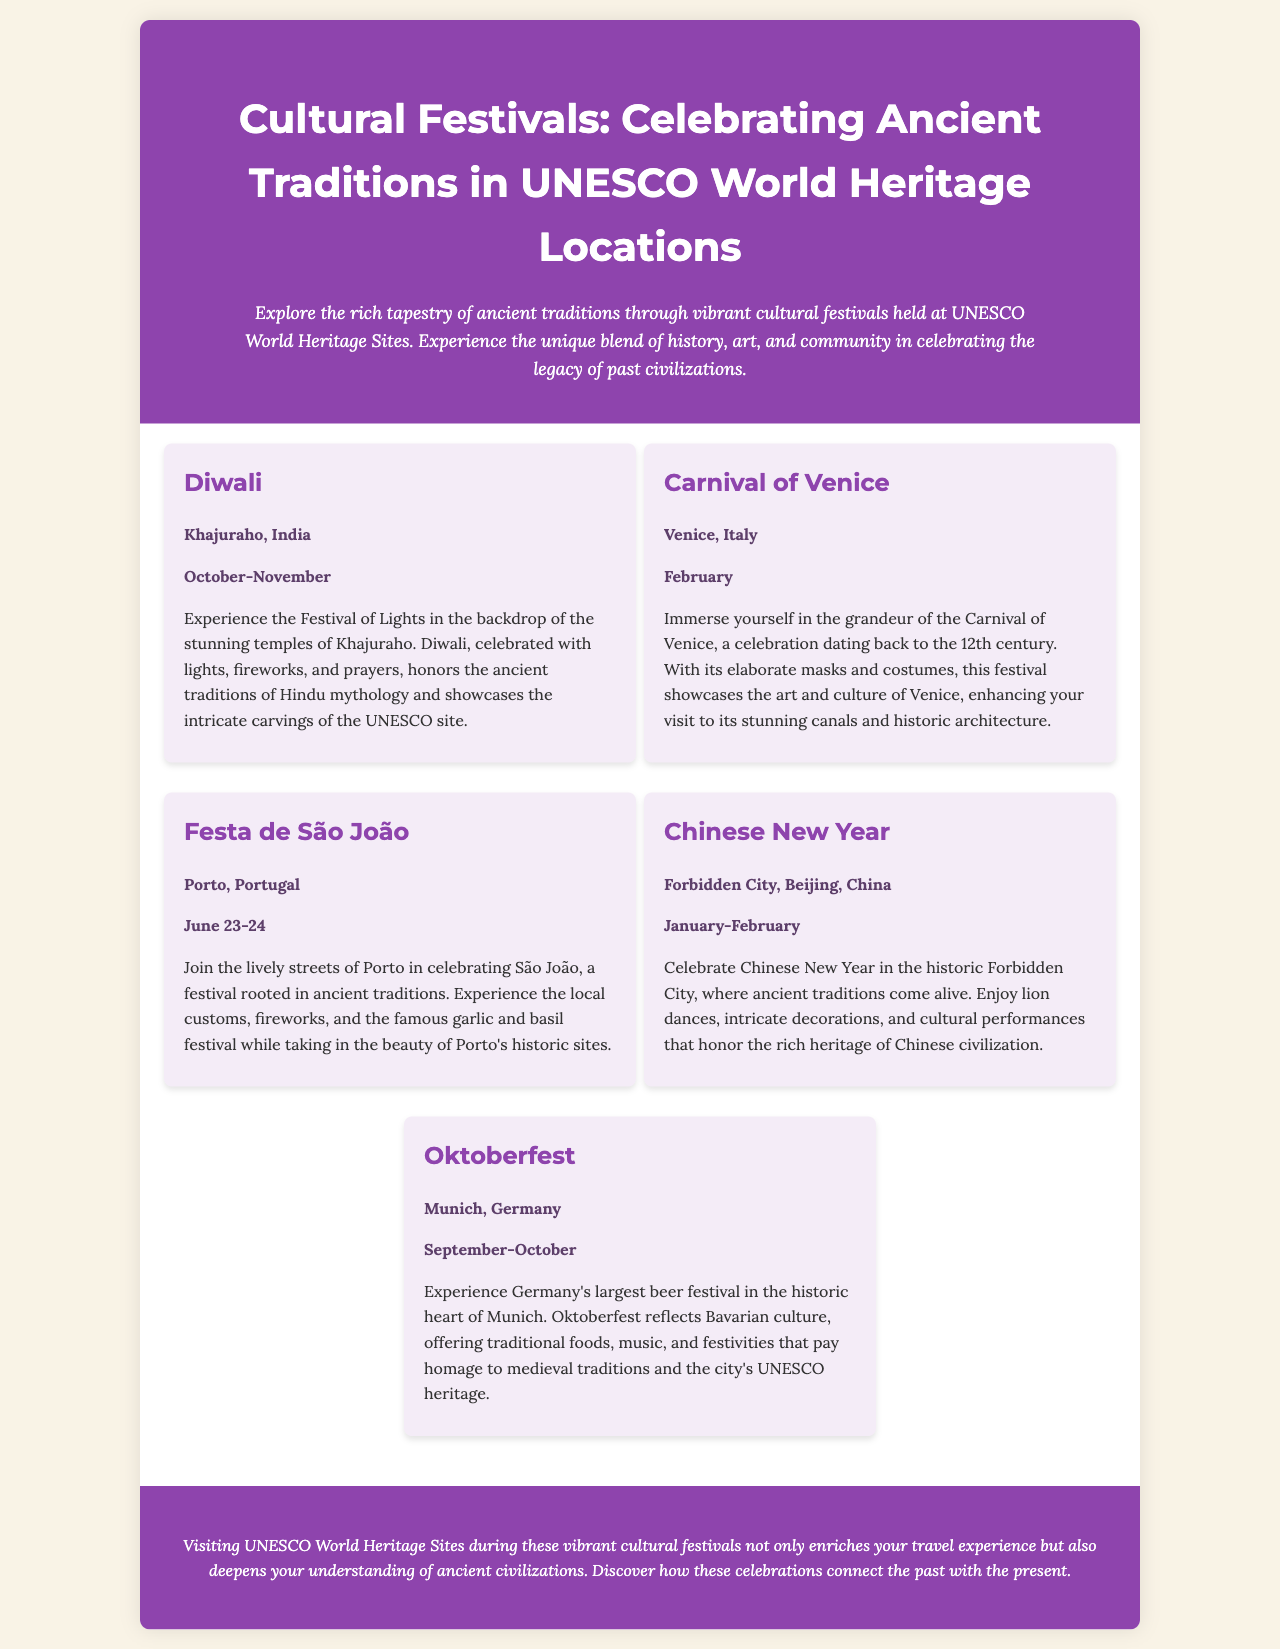what is the title of the brochure? The title is presented in the header of the document and summarizes the content focus, which is cultural festivals at UNESCO World Heritage sites.
Answer: Cultural Festivals: Celebrating Ancient Traditions in UNESCO World Heritage Locations what festival is celebrated in Khajuraho, India? The document mentions a specific festival celebrated in Khajuraho, highlighting its importance and context.
Answer: Diwali when does the Carnival of Venice take place? The date for this festival is clearly stated in the document, indicating the month of celebration.
Answer: February which festival features lion dances and cultural performances? The document describes a festival that includes specific traditional performances and is celebrated at a notable historical site.
Answer: Chinese New Year how many festivals are mentioned in the brochure? The count of the festivals can be derived by tallying the distinct entries presented in the document.
Answer: Five what ancient traditions does the Festa de São João celebrate? The document references specific heritage elements associated with the festival taking place in Porto.
Answer: Ancient traditions which city hosts Oktoberfest? The location of this significant cultural event can be identified from the text detailing each festival's location.
Answer: Munich what is the essence of visiting UNESCO World Heritage Sites during festivals? The conclusion of the document emphasizes the benefits of traveling to these sites during festival times.
Answer: Enrichment of travel experience 